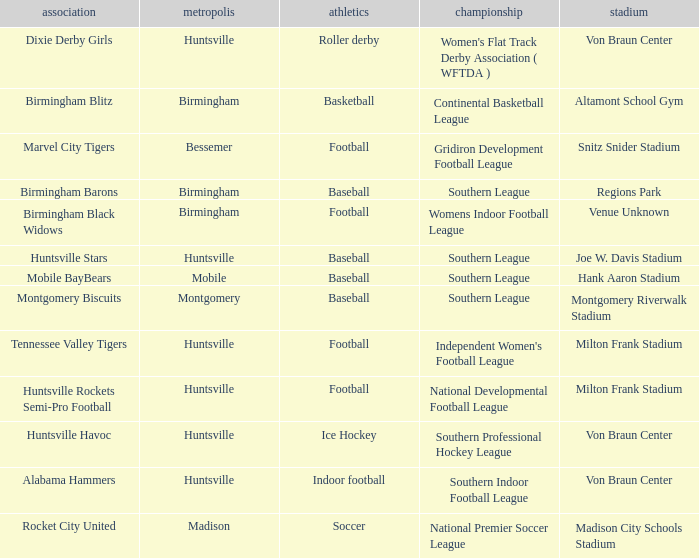Which venue hosted the Dixie Derby Girls? Von Braun Center. 